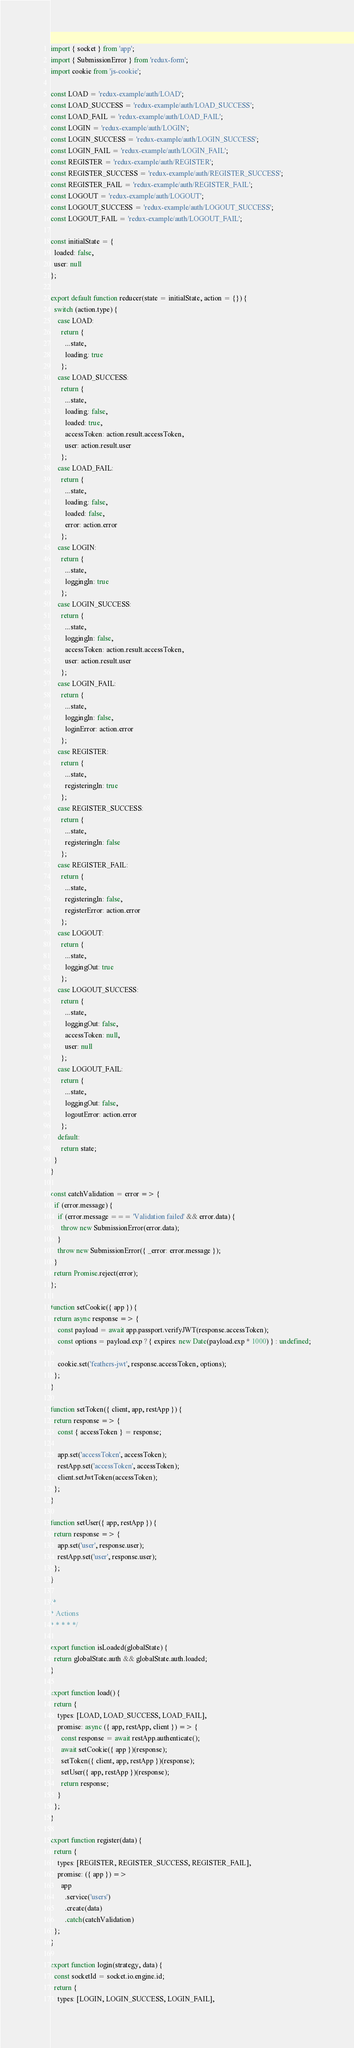<code> <loc_0><loc_0><loc_500><loc_500><_JavaScript_>import { socket } from 'app';
import { SubmissionError } from 'redux-form';
import cookie from 'js-cookie';

const LOAD = 'redux-example/auth/LOAD';
const LOAD_SUCCESS = 'redux-example/auth/LOAD_SUCCESS';
const LOAD_FAIL = 'redux-example/auth/LOAD_FAIL';
const LOGIN = 'redux-example/auth/LOGIN';
const LOGIN_SUCCESS = 'redux-example/auth/LOGIN_SUCCESS';
const LOGIN_FAIL = 'redux-example/auth/LOGIN_FAIL';
const REGISTER = 'redux-example/auth/REGISTER';
const REGISTER_SUCCESS = 'redux-example/auth/REGISTER_SUCCESS';
const REGISTER_FAIL = 'redux-example/auth/REGISTER_FAIL';
const LOGOUT = 'redux-example/auth/LOGOUT';
const LOGOUT_SUCCESS = 'redux-example/auth/LOGOUT_SUCCESS';
const LOGOUT_FAIL = 'redux-example/auth/LOGOUT_FAIL';

const initialState = {
  loaded: false,
  user: null
};

export default function reducer(state = initialState, action = {}) {
  switch (action.type) {
    case LOAD:
      return {
        ...state,
        loading: true
      };
    case LOAD_SUCCESS:
      return {
        ...state,
        loading: false,
        loaded: true,
        accessToken: action.result.accessToken,
        user: action.result.user
      };
    case LOAD_FAIL:
      return {
        ...state,
        loading: false,
        loaded: false,
        error: action.error
      };
    case LOGIN:
      return {
        ...state,
        loggingIn: true
      };
    case LOGIN_SUCCESS:
      return {
        ...state,
        loggingIn: false,
        accessToken: action.result.accessToken,
        user: action.result.user
      };
    case LOGIN_FAIL:
      return {
        ...state,
        loggingIn: false,
        loginError: action.error
      };
    case REGISTER:
      return {
        ...state,
        registeringIn: true
      };
    case REGISTER_SUCCESS:
      return {
        ...state,
        registeringIn: false
      };
    case REGISTER_FAIL:
      return {
        ...state,
        registeringIn: false,
        registerError: action.error
      };
    case LOGOUT:
      return {
        ...state,
        loggingOut: true
      };
    case LOGOUT_SUCCESS:
      return {
        ...state,
        loggingOut: false,
        accessToken: null,
        user: null
      };
    case LOGOUT_FAIL:
      return {
        ...state,
        loggingOut: false,
        logoutError: action.error
      };
    default:
      return state;
  }
}

const catchValidation = error => {
  if (error.message) {
    if (error.message === 'Validation failed' && error.data) {
      throw new SubmissionError(error.data);
    }
    throw new SubmissionError({ _error: error.message });
  }
  return Promise.reject(error);
};

function setCookie({ app }) {
  return async response => {
    const payload = await app.passport.verifyJWT(response.accessToken);
    const options = payload.exp ? { expires: new Date(payload.exp * 1000) } : undefined;

    cookie.set('feathers-jwt', response.accessToken, options);
  };
}

function setToken({ client, app, restApp }) {
  return response => {
    const { accessToken } = response;

    app.set('accessToken', accessToken);
    restApp.set('accessToken', accessToken);
    client.setJwtToken(accessToken);
  };
}

function setUser({ app, restApp }) {
  return response => {
    app.set('user', response.user);
    restApp.set('user', response.user);
  };
}

/*
* Actions
* * * * */

export function isLoaded(globalState) {
  return globalState.auth && globalState.auth.loaded;
}

export function load() {
  return {
    types: [LOAD, LOAD_SUCCESS, LOAD_FAIL],
    promise: async ({ app, restApp, client }) => {
      const response = await restApp.authenticate();
      await setCookie({ app })(response);
      setToken({ client, app, restApp })(response);
      setUser({ app, restApp })(response);
      return response;
    }
  };
}

export function register(data) {
  return {
    types: [REGISTER, REGISTER_SUCCESS, REGISTER_FAIL],
    promise: ({ app }) =>
      app
        .service('users')
        .create(data)
        .catch(catchValidation)
  };
}

export function login(strategy, data) {
  const socketId = socket.io.engine.id;
  return {
    types: [LOGIN, LOGIN_SUCCESS, LOGIN_FAIL],</code> 